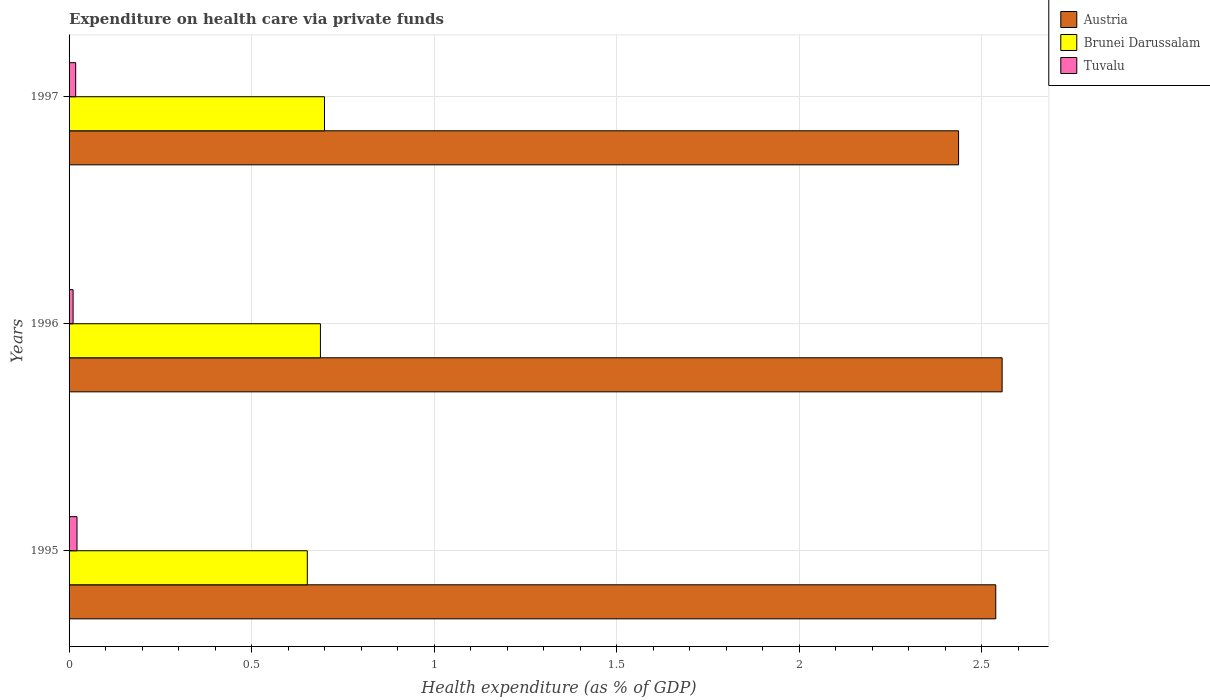Are the number of bars per tick equal to the number of legend labels?
Your answer should be very brief. Yes. How many bars are there on the 2nd tick from the bottom?
Your response must be concise. 3. What is the label of the 2nd group of bars from the top?
Your response must be concise. 1996. In how many cases, is the number of bars for a given year not equal to the number of legend labels?
Give a very brief answer. 0. What is the expenditure made on health care in Brunei Darussalam in 1996?
Give a very brief answer. 0.69. Across all years, what is the maximum expenditure made on health care in Brunei Darussalam?
Your answer should be compact. 0.7. Across all years, what is the minimum expenditure made on health care in Tuvalu?
Provide a short and direct response. 0.01. In which year was the expenditure made on health care in Brunei Darussalam maximum?
Make the answer very short. 1997. What is the total expenditure made on health care in Brunei Darussalam in the graph?
Provide a succinct answer. 2.04. What is the difference between the expenditure made on health care in Brunei Darussalam in 1995 and that in 1996?
Give a very brief answer. -0.04. What is the difference between the expenditure made on health care in Austria in 1996 and the expenditure made on health care in Brunei Darussalam in 1995?
Your answer should be very brief. 1.9. What is the average expenditure made on health care in Tuvalu per year?
Ensure brevity in your answer.  0.02. In the year 1995, what is the difference between the expenditure made on health care in Brunei Darussalam and expenditure made on health care in Austria?
Provide a short and direct response. -1.89. In how many years, is the expenditure made on health care in Tuvalu greater than 1.5 %?
Give a very brief answer. 0. What is the ratio of the expenditure made on health care in Austria in 1995 to that in 1997?
Keep it short and to the point. 1.04. What is the difference between the highest and the second highest expenditure made on health care in Austria?
Offer a terse response. 0.02. What is the difference between the highest and the lowest expenditure made on health care in Brunei Darussalam?
Offer a very short reply. 0.05. What does the 1st bar from the top in 1997 represents?
Provide a short and direct response. Tuvalu. What does the 3rd bar from the bottom in 1996 represents?
Your answer should be compact. Tuvalu. Is it the case that in every year, the sum of the expenditure made on health care in Tuvalu and expenditure made on health care in Austria is greater than the expenditure made on health care in Brunei Darussalam?
Make the answer very short. Yes. What is the difference between two consecutive major ticks on the X-axis?
Your answer should be very brief. 0.5. Are the values on the major ticks of X-axis written in scientific E-notation?
Your answer should be very brief. No. Where does the legend appear in the graph?
Keep it short and to the point. Top right. What is the title of the graph?
Make the answer very short. Expenditure on health care via private funds. Does "Nepal" appear as one of the legend labels in the graph?
Provide a succinct answer. No. What is the label or title of the X-axis?
Offer a very short reply. Health expenditure (as % of GDP). What is the Health expenditure (as % of GDP) of Austria in 1995?
Your answer should be compact. 2.54. What is the Health expenditure (as % of GDP) in Brunei Darussalam in 1995?
Keep it short and to the point. 0.65. What is the Health expenditure (as % of GDP) of Tuvalu in 1995?
Give a very brief answer. 0.02. What is the Health expenditure (as % of GDP) of Austria in 1996?
Your response must be concise. 2.56. What is the Health expenditure (as % of GDP) of Brunei Darussalam in 1996?
Give a very brief answer. 0.69. What is the Health expenditure (as % of GDP) in Tuvalu in 1996?
Keep it short and to the point. 0.01. What is the Health expenditure (as % of GDP) of Austria in 1997?
Offer a very short reply. 2.44. What is the Health expenditure (as % of GDP) of Brunei Darussalam in 1997?
Keep it short and to the point. 0.7. What is the Health expenditure (as % of GDP) in Tuvalu in 1997?
Your answer should be compact. 0.02. Across all years, what is the maximum Health expenditure (as % of GDP) in Austria?
Keep it short and to the point. 2.56. Across all years, what is the maximum Health expenditure (as % of GDP) in Brunei Darussalam?
Offer a terse response. 0.7. Across all years, what is the maximum Health expenditure (as % of GDP) of Tuvalu?
Your response must be concise. 0.02. Across all years, what is the minimum Health expenditure (as % of GDP) in Austria?
Keep it short and to the point. 2.44. Across all years, what is the minimum Health expenditure (as % of GDP) in Brunei Darussalam?
Offer a very short reply. 0.65. Across all years, what is the minimum Health expenditure (as % of GDP) of Tuvalu?
Give a very brief answer. 0.01. What is the total Health expenditure (as % of GDP) in Austria in the graph?
Make the answer very short. 7.53. What is the total Health expenditure (as % of GDP) in Brunei Darussalam in the graph?
Keep it short and to the point. 2.04. What is the total Health expenditure (as % of GDP) of Tuvalu in the graph?
Provide a succinct answer. 0.05. What is the difference between the Health expenditure (as % of GDP) in Austria in 1995 and that in 1996?
Keep it short and to the point. -0.02. What is the difference between the Health expenditure (as % of GDP) in Brunei Darussalam in 1995 and that in 1996?
Your response must be concise. -0.04. What is the difference between the Health expenditure (as % of GDP) in Tuvalu in 1995 and that in 1996?
Offer a terse response. 0.01. What is the difference between the Health expenditure (as % of GDP) in Austria in 1995 and that in 1997?
Your answer should be compact. 0.1. What is the difference between the Health expenditure (as % of GDP) in Brunei Darussalam in 1995 and that in 1997?
Provide a succinct answer. -0.05. What is the difference between the Health expenditure (as % of GDP) in Tuvalu in 1995 and that in 1997?
Provide a short and direct response. 0. What is the difference between the Health expenditure (as % of GDP) in Austria in 1996 and that in 1997?
Provide a short and direct response. 0.12. What is the difference between the Health expenditure (as % of GDP) in Brunei Darussalam in 1996 and that in 1997?
Your answer should be very brief. -0.01. What is the difference between the Health expenditure (as % of GDP) in Tuvalu in 1996 and that in 1997?
Offer a terse response. -0.01. What is the difference between the Health expenditure (as % of GDP) in Austria in 1995 and the Health expenditure (as % of GDP) in Brunei Darussalam in 1996?
Your answer should be compact. 1.85. What is the difference between the Health expenditure (as % of GDP) of Austria in 1995 and the Health expenditure (as % of GDP) of Tuvalu in 1996?
Provide a short and direct response. 2.53. What is the difference between the Health expenditure (as % of GDP) in Brunei Darussalam in 1995 and the Health expenditure (as % of GDP) in Tuvalu in 1996?
Your response must be concise. 0.64. What is the difference between the Health expenditure (as % of GDP) of Austria in 1995 and the Health expenditure (as % of GDP) of Brunei Darussalam in 1997?
Provide a short and direct response. 1.84. What is the difference between the Health expenditure (as % of GDP) in Austria in 1995 and the Health expenditure (as % of GDP) in Tuvalu in 1997?
Your response must be concise. 2.52. What is the difference between the Health expenditure (as % of GDP) in Brunei Darussalam in 1995 and the Health expenditure (as % of GDP) in Tuvalu in 1997?
Offer a terse response. 0.63. What is the difference between the Health expenditure (as % of GDP) of Austria in 1996 and the Health expenditure (as % of GDP) of Brunei Darussalam in 1997?
Give a very brief answer. 1.86. What is the difference between the Health expenditure (as % of GDP) of Austria in 1996 and the Health expenditure (as % of GDP) of Tuvalu in 1997?
Ensure brevity in your answer.  2.54. What is the difference between the Health expenditure (as % of GDP) of Brunei Darussalam in 1996 and the Health expenditure (as % of GDP) of Tuvalu in 1997?
Offer a terse response. 0.67. What is the average Health expenditure (as % of GDP) in Austria per year?
Provide a short and direct response. 2.51. What is the average Health expenditure (as % of GDP) of Brunei Darussalam per year?
Give a very brief answer. 0.68. What is the average Health expenditure (as % of GDP) of Tuvalu per year?
Your answer should be very brief. 0.02. In the year 1995, what is the difference between the Health expenditure (as % of GDP) of Austria and Health expenditure (as % of GDP) of Brunei Darussalam?
Your answer should be compact. 1.89. In the year 1995, what is the difference between the Health expenditure (as % of GDP) in Austria and Health expenditure (as % of GDP) in Tuvalu?
Provide a succinct answer. 2.52. In the year 1995, what is the difference between the Health expenditure (as % of GDP) in Brunei Darussalam and Health expenditure (as % of GDP) in Tuvalu?
Make the answer very short. 0.63. In the year 1996, what is the difference between the Health expenditure (as % of GDP) in Austria and Health expenditure (as % of GDP) in Brunei Darussalam?
Make the answer very short. 1.87. In the year 1996, what is the difference between the Health expenditure (as % of GDP) in Austria and Health expenditure (as % of GDP) in Tuvalu?
Give a very brief answer. 2.55. In the year 1996, what is the difference between the Health expenditure (as % of GDP) in Brunei Darussalam and Health expenditure (as % of GDP) in Tuvalu?
Keep it short and to the point. 0.68. In the year 1997, what is the difference between the Health expenditure (as % of GDP) in Austria and Health expenditure (as % of GDP) in Brunei Darussalam?
Provide a succinct answer. 1.74. In the year 1997, what is the difference between the Health expenditure (as % of GDP) of Austria and Health expenditure (as % of GDP) of Tuvalu?
Make the answer very short. 2.42. In the year 1997, what is the difference between the Health expenditure (as % of GDP) of Brunei Darussalam and Health expenditure (as % of GDP) of Tuvalu?
Provide a succinct answer. 0.68. What is the ratio of the Health expenditure (as % of GDP) of Austria in 1995 to that in 1996?
Offer a terse response. 0.99. What is the ratio of the Health expenditure (as % of GDP) in Brunei Darussalam in 1995 to that in 1996?
Ensure brevity in your answer.  0.95. What is the ratio of the Health expenditure (as % of GDP) of Tuvalu in 1995 to that in 1996?
Provide a short and direct response. 1.97. What is the ratio of the Health expenditure (as % of GDP) of Austria in 1995 to that in 1997?
Your response must be concise. 1.04. What is the ratio of the Health expenditure (as % of GDP) in Brunei Darussalam in 1995 to that in 1997?
Keep it short and to the point. 0.93. What is the ratio of the Health expenditure (as % of GDP) of Tuvalu in 1995 to that in 1997?
Ensure brevity in your answer.  1.2. What is the ratio of the Health expenditure (as % of GDP) of Austria in 1996 to that in 1997?
Provide a short and direct response. 1.05. What is the ratio of the Health expenditure (as % of GDP) in Brunei Darussalam in 1996 to that in 1997?
Provide a short and direct response. 0.98. What is the ratio of the Health expenditure (as % of GDP) in Tuvalu in 1996 to that in 1997?
Offer a terse response. 0.61. What is the difference between the highest and the second highest Health expenditure (as % of GDP) of Austria?
Give a very brief answer. 0.02. What is the difference between the highest and the second highest Health expenditure (as % of GDP) of Brunei Darussalam?
Offer a very short reply. 0.01. What is the difference between the highest and the second highest Health expenditure (as % of GDP) in Tuvalu?
Provide a succinct answer. 0. What is the difference between the highest and the lowest Health expenditure (as % of GDP) of Austria?
Your answer should be very brief. 0.12. What is the difference between the highest and the lowest Health expenditure (as % of GDP) in Brunei Darussalam?
Offer a terse response. 0.05. What is the difference between the highest and the lowest Health expenditure (as % of GDP) of Tuvalu?
Offer a very short reply. 0.01. 